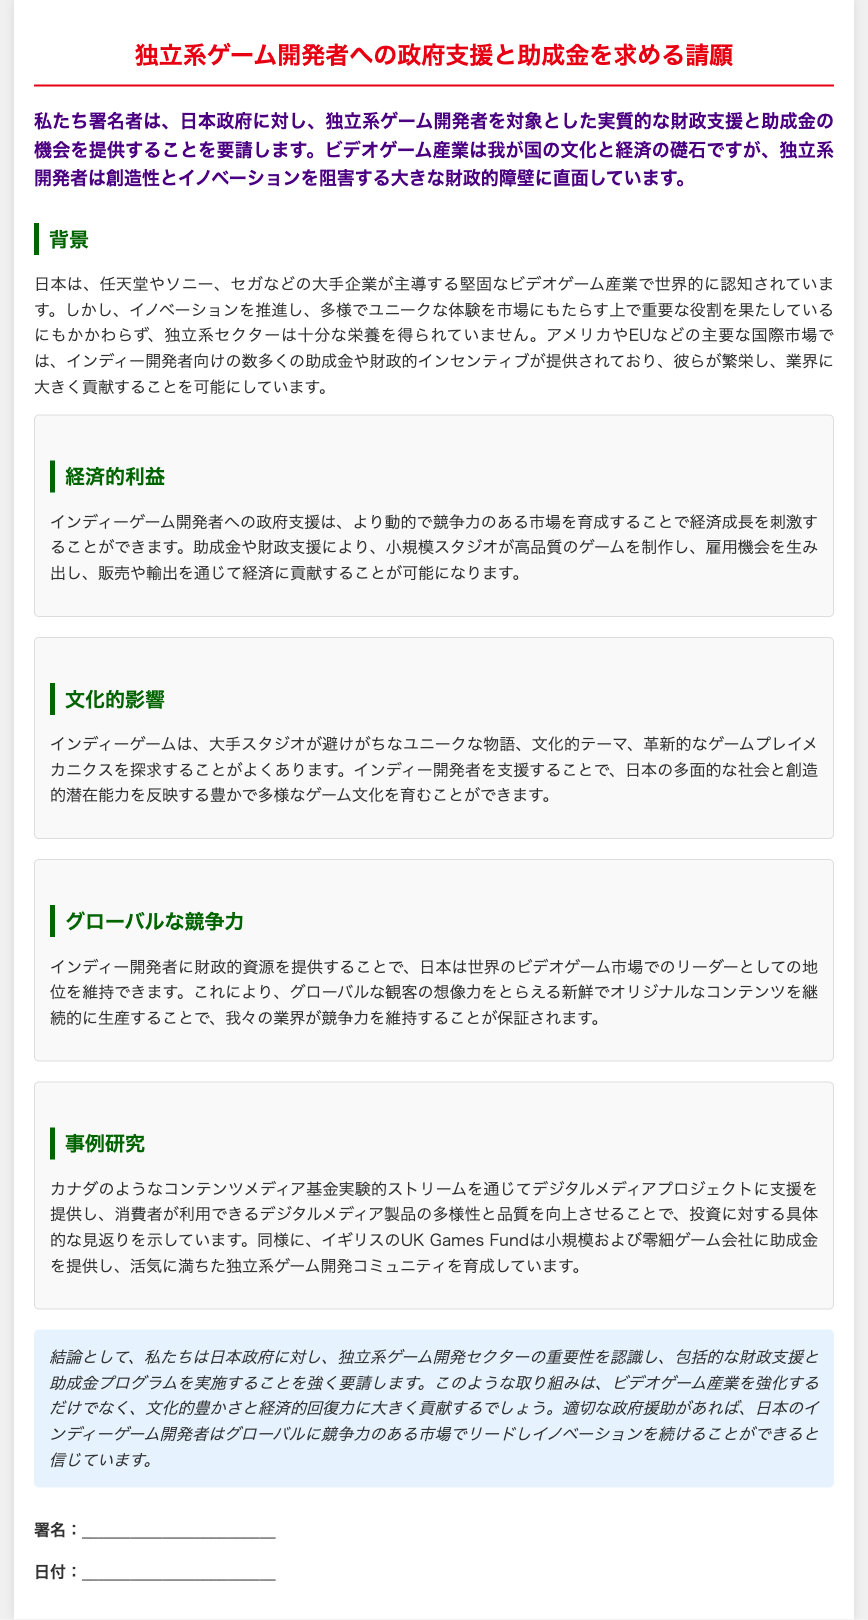What is the title of the petition? The title appears at the top of the document and states the purpose of the appeal for government support.
Answer: 独立系ゲーム開発者への政府支援と助成金を求める請願 Who are the signers appealing to? The introduction specifies that the signers are appealing to a specific entity for support.
Answer: 日本政府 What is a primary reason given for government support? The main points highlight various benefits of supporting indie developers, including economic growth.
Answer: 経済成長 Which country is mentioned as providing grants for indie developers? The document compares Japan with other countries regarding support for indie developers.
Answer: カナダ What is the impact of indie games according to the document? The document outlines the significance and contribution of indie games to culture and economy.
Answer: 文化的影響 What is the conclusion's main request to the government? The conclusion summarizes the main call to action from the petition.
Answer: 財政支援と助成金プログラム How does the petition describe indie games in the context of market competition? The document discusses the potential for indie developers in the global marketplace.
Answer: グローバルな競争力 According to the petition, what kind of content do indie games often explore? The text specifies the narrative themes present in indie games as part of their contribution to the gaming industry.
Answer: ユニークな物語、文化的テーマ、革新的なゲームプレイメカニクス 